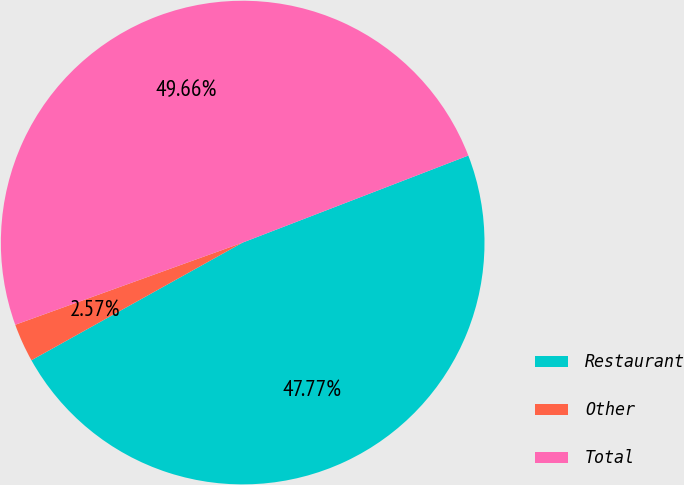<chart> <loc_0><loc_0><loc_500><loc_500><pie_chart><fcel>Restaurant<fcel>Other<fcel>Total<nl><fcel>47.77%<fcel>2.57%<fcel>49.66%<nl></chart> 